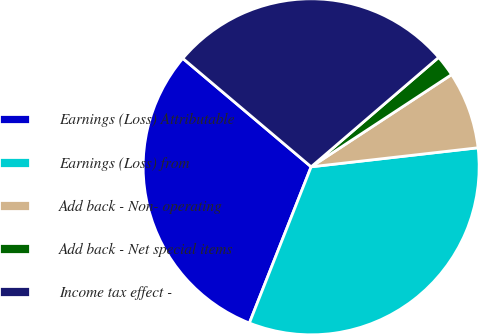Convert chart to OTSL. <chart><loc_0><loc_0><loc_500><loc_500><pie_chart><fcel>Earnings (Loss) Attributable<fcel>Earnings (Loss) from<fcel>Add back - Non- operating<fcel>Add back - Net special items<fcel>Income tax effect -<nl><fcel>30.17%<fcel>32.8%<fcel>7.44%<fcel>2.04%<fcel>27.55%<nl></chart> 